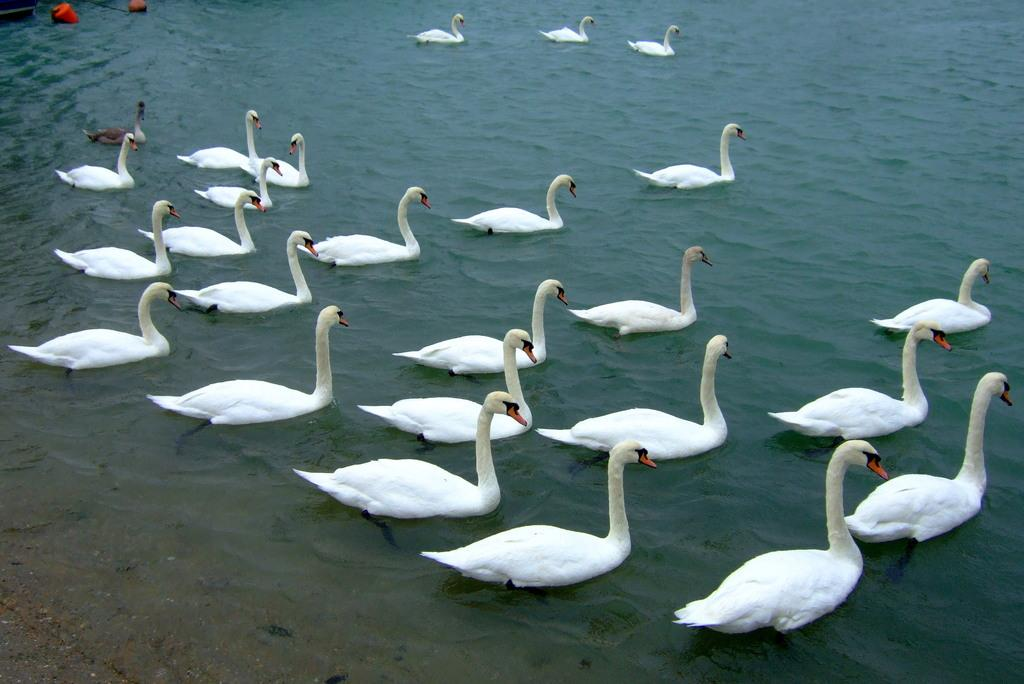What type of animals can be seen in the image? Birds can be seen in the water. What else is present in the water besides the birds? There is an object in the water. What is the color of the object in the water? The object is red in color. Where is the red object located in the image? The object is located at the top left of the image. How is the honey being used in the image? There is no honey present in the image. 